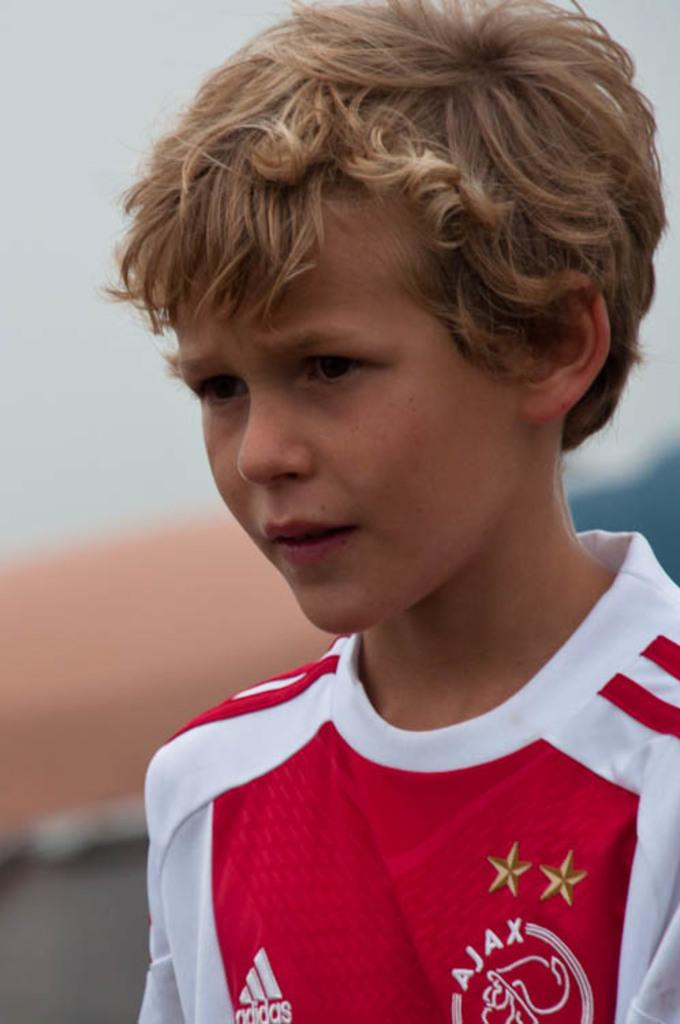<image>
Share a concise interpretation of the image provided. A young blonde boy with a red and white Adidas shirt 